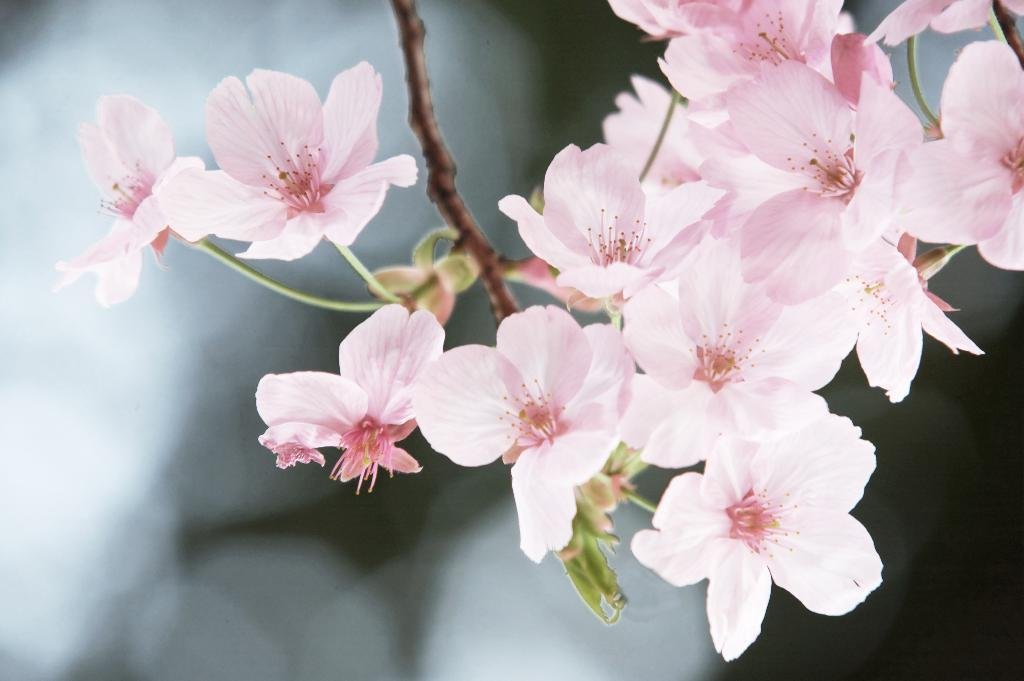What color are the flowers in the image? The flowers in the image are pink. What can be seen in the middle of the flowers? There is a stem in the middle of the flowers. What is present at the bottom of the flowers? There is a leaf at the bottom of the flowers. How would you describe the background of the image? The background of the image is blurred. What month is it in the image? The image does not provide any information about the month or time of year. Can you see a baby in the image? There is no baby present in the image; it features flowers with a stem and leaf. 